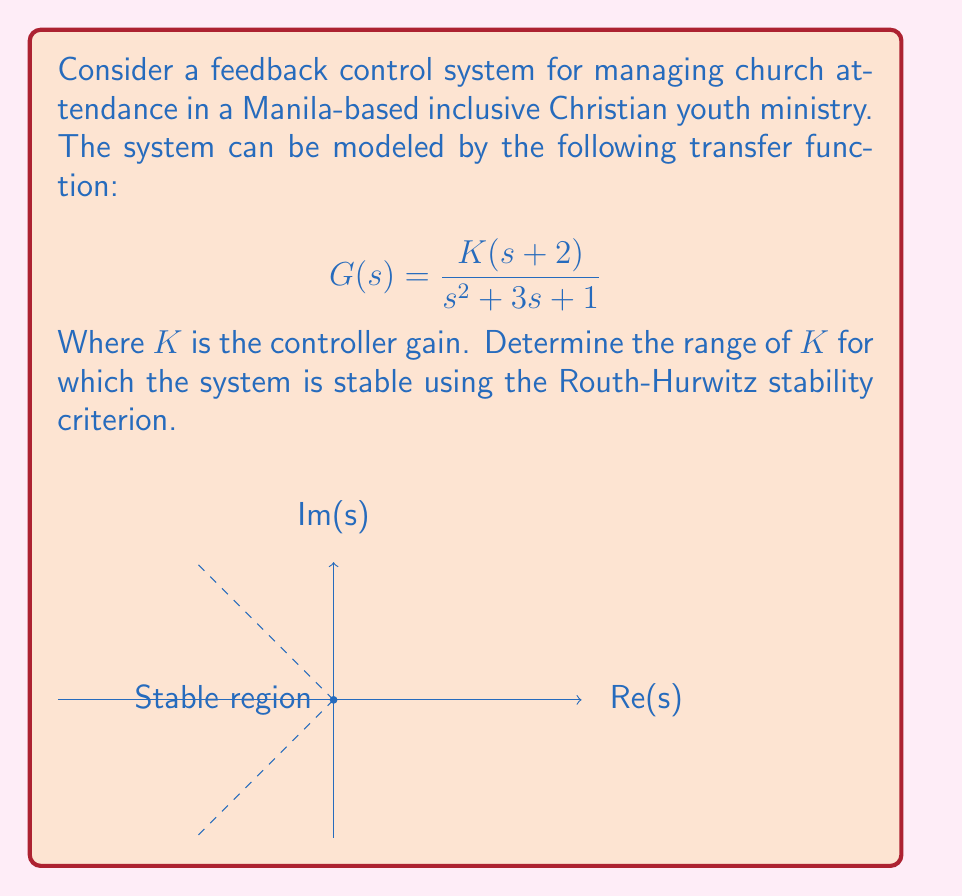Give your solution to this math problem. To analyze the stability of this system, we'll use the Routh-Hurwitz stability criterion:

1) First, write the characteristic equation:
   $$s^2 + 3s + 1 + K(s+2) = 0$$
   $$s^2 + (3+K)s + (1+2K) = 0$$

2) Construct the Routh array:
   $$\begin{array}{c|c}
   s^2 & 1 & 1+2K \\
   s^1 & 3+K & 0 \\
   s^0 & 1+2K & 0
   \end{array}$$

3) For stability, all elements in the first column must be positive:
   
   $1 > 0$ (always true)
   $3+K > 0$
   $1+2K > 0$

4) From $3+K > 0$, we get:
   $K > -3$

5) From $1+2K > 0$, we get:
   $K > -\frac{1}{2}$

6) Combining these conditions, we need:
   $K > \max(-3, -\frac{1}{2}) = -\frac{1}{2}$

Therefore, the system is stable for all $K > -\frac{1}{2}$.

This result suggests that the feedback control system for managing church attendance in the inclusive youth ministry will remain stable as long as the controller gain $K$ is greater than $-\frac{1}{2}$, allowing for a wide range of positive gains to be implemented effectively.
Answer: $K > -\frac{1}{2}$ 